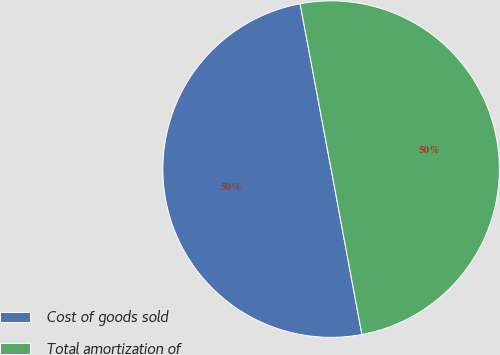Convert chart. <chart><loc_0><loc_0><loc_500><loc_500><pie_chart><fcel>Cost of goods sold<fcel>Total amortization of<nl><fcel>49.98%<fcel>50.02%<nl></chart> 